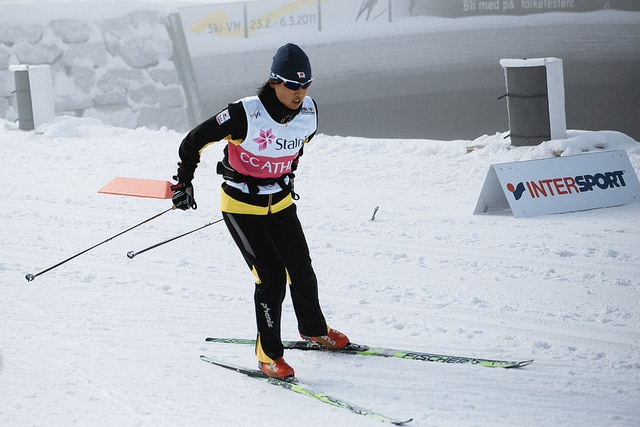Describe the objects in this image and their specific colors. I can see people in lightgray, black, lightblue, and darkgray tones and skis in lightgray, darkgray, gray, and black tones in this image. 